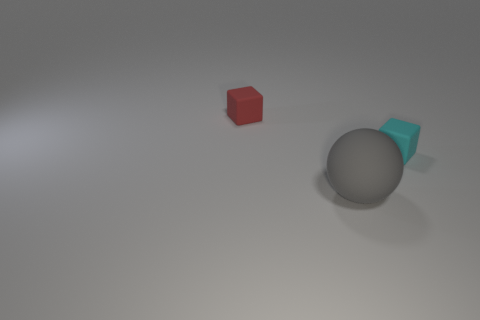Add 2 big green matte things. How many objects exist? 5 Subtract 2 blocks. How many blocks are left? 0 Subtract all balls. How many objects are left? 2 Subtract all blue cylinders. How many red blocks are left? 1 Subtract all red cubes. How many cubes are left? 1 Add 2 small objects. How many small objects exist? 4 Subtract 0 brown blocks. How many objects are left? 3 Subtract all brown balls. Subtract all purple cubes. How many balls are left? 1 Subtract all matte spheres. Subtract all small red metallic cylinders. How many objects are left? 2 Add 2 gray matte spheres. How many gray matte spheres are left? 3 